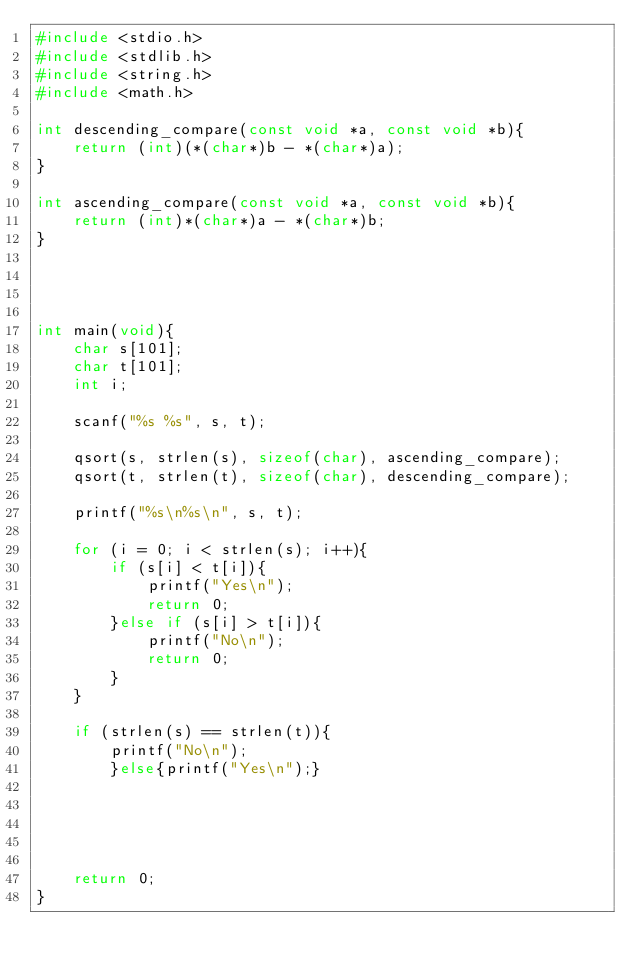<code> <loc_0><loc_0><loc_500><loc_500><_C_>#include <stdio.h>
#include <stdlib.h>
#include <string.h>
#include <math.h>

int descending_compare(const void *a, const void *b){
    return (int)(*(char*)b - *(char*)a);
}

int ascending_compare(const void *a, const void *b){
    return (int)*(char*)a - *(char*)b;
}




int main(void){
    char s[101];
    char t[101];
    int i;

    scanf("%s %s", s, t);

    qsort(s, strlen(s), sizeof(char), ascending_compare);
    qsort(t, strlen(t), sizeof(char), descending_compare);

    printf("%s\n%s\n", s, t);

    for (i = 0; i < strlen(s); i++){
        if (s[i] < t[i]){
            printf("Yes\n");
            return 0;
        }else if (s[i] > t[i]){
            printf("No\n");
            return 0;
        }
    }

    if (strlen(s) == strlen(t)){
        printf("No\n");
        }else{printf("Yes\n");}
    
    
    
    
    
    return 0;
}</code> 